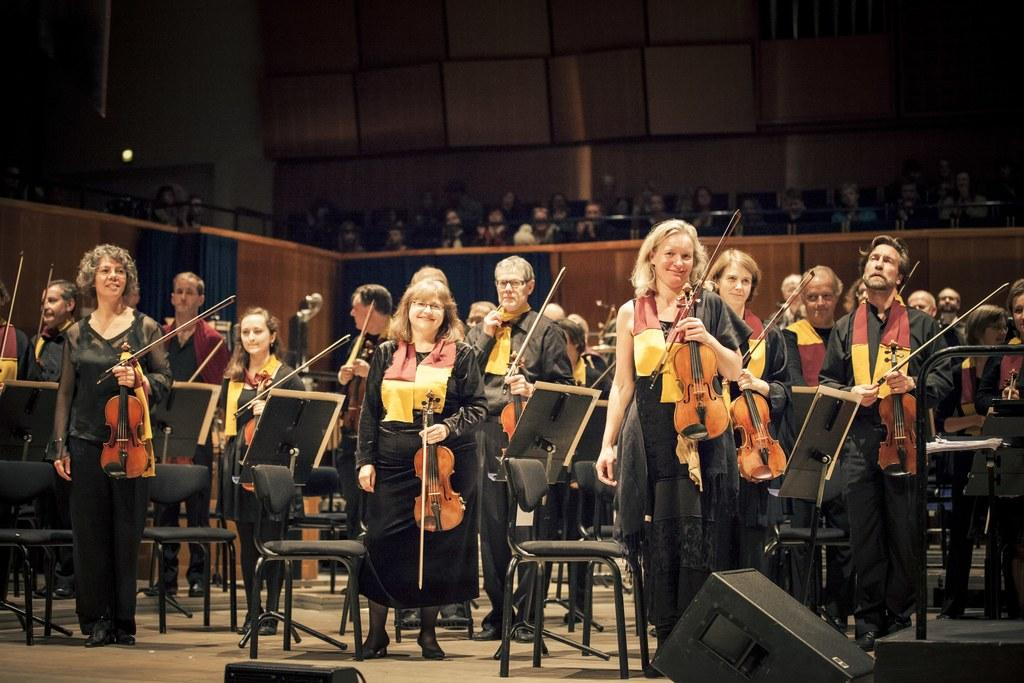What is the main subject of the image? The main subject of the image is a group of people. What are some of the people holding in their hands? Some people are holding violins in their hands. What objects are in front of the people? There are stands and chairs in front of the people. What type of scene is taking place in the yard, and how does anger play a role in it? There is no mention of a scene or yard in the image, and anger is not a relevant factor in the image. The image features a group of people holding violins, with stands and chairs in front of them. 